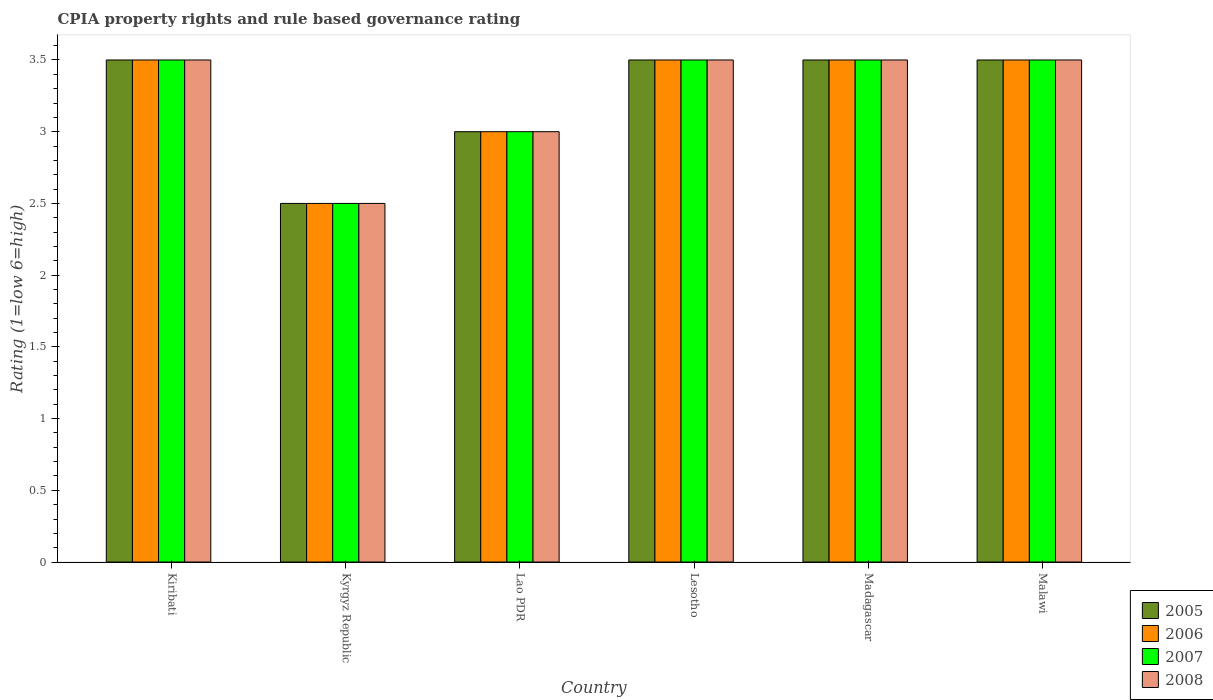How many groups of bars are there?
Your response must be concise. 6. How many bars are there on the 5th tick from the right?
Offer a terse response. 4. What is the label of the 4th group of bars from the left?
Your response must be concise. Lesotho. Across all countries, what is the maximum CPIA rating in 2005?
Your answer should be compact. 3.5. In which country was the CPIA rating in 2006 maximum?
Your answer should be compact. Kiribati. In which country was the CPIA rating in 2006 minimum?
Provide a succinct answer. Kyrgyz Republic. What is the difference between the CPIA rating in 2005 in Kiribati and that in Lao PDR?
Ensure brevity in your answer.  0.5. What is the difference between the CPIA rating in 2008 in Kyrgyz Republic and the CPIA rating in 2005 in Lesotho?
Provide a succinct answer. -1. What is the average CPIA rating in 2005 per country?
Offer a terse response. 3.25. What is the difference between the CPIA rating of/in 2007 and CPIA rating of/in 2006 in Lao PDR?
Your answer should be compact. 0. In how many countries, is the CPIA rating in 2006 greater than 3.4?
Provide a succinct answer. 4. What is the ratio of the CPIA rating in 2006 in Lesotho to that in Malawi?
Keep it short and to the point. 1. Is the sum of the CPIA rating in 2005 in Lesotho and Madagascar greater than the maximum CPIA rating in 2006 across all countries?
Provide a short and direct response. Yes. Is it the case that in every country, the sum of the CPIA rating in 2005 and CPIA rating in 2008 is greater than the sum of CPIA rating in 2006 and CPIA rating in 2007?
Your answer should be compact. No. What does the 4th bar from the left in Lao PDR represents?
Ensure brevity in your answer.  2008. What does the 1st bar from the right in Lao PDR represents?
Offer a very short reply. 2008. Are the values on the major ticks of Y-axis written in scientific E-notation?
Provide a succinct answer. No. Does the graph contain any zero values?
Keep it short and to the point. No. Where does the legend appear in the graph?
Offer a very short reply. Bottom right. How many legend labels are there?
Ensure brevity in your answer.  4. What is the title of the graph?
Your response must be concise. CPIA property rights and rule based governance rating. What is the label or title of the X-axis?
Make the answer very short. Country. What is the label or title of the Y-axis?
Keep it short and to the point. Rating (1=low 6=high). What is the Rating (1=low 6=high) of 2007 in Kiribati?
Offer a very short reply. 3.5. What is the Rating (1=low 6=high) of 2008 in Kiribati?
Give a very brief answer. 3.5. What is the Rating (1=low 6=high) in 2005 in Lao PDR?
Provide a short and direct response. 3. What is the Rating (1=low 6=high) in 2007 in Lao PDR?
Your answer should be compact. 3. What is the Rating (1=low 6=high) in 2006 in Lesotho?
Your answer should be very brief. 3.5. What is the Rating (1=low 6=high) in 2007 in Lesotho?
Your answer should be very brief. 3.5. What is the Rating (1=low 6=high) in 2008 in Lesotho?
Give a very brief answer. 3.5. What is the Rating (1=low 6=high) of 2005 in Madagascar?
Your answer should be very brief. 3.5. What is the Rating (1=low 6=high) in 2007 in Madagascar?
Your answer should be very brief. 3.5. What is the Rating (1=low 6=high) in 2008 in Malawi?
Offer a very short reply. 3.5. Across all countries, what is the maximum Rating (1=low 6=high) in 2007?
Your answer should be compact. 3.5. Across all countries, what is the minimum Rating (1=low 6=high) in 2006?
Offer a very short reply. 2.5. Across all countries, what is the minimum Rating (1=low 6=high) in 2007?
Make the answer very short. 2.5. Across all countries, what is the minimum Rating (1=low 6=high) in 2008?
Your answer should be very brief. 2.5. What is the total Rating (1=low 6=high) of 2006 in the graph?
Your response must be concise. 19.5. What is the total Rating (1=low 6=high) in 2007 in the graph?
Your answer should be very brief. 19.5. What is the total Rating (1=low 6=high) in 2008 in the graph?
Offer a terse response. 19.5. What is the difference between the Rating (1=low 6=high) of 2005 in Kiribati and that in Kyrgyz Republic?
Your response must be concise. 1. What is the difference between the Rating (1=low 6=high) in 2006 in Kiribati and that in Kyrgyz Republic?
Offer a very short reply. 1. What is the difference between the Rating (1=low 6=high) of 2007 in Kiribati and that in Kyrgyz Republic?
Keep it short and to the point. 1. What is the difference between the Rating (1=low 6=high) in 2008 in Kiribati and that in Kyrgyz Republic?
Keep it short and to the point. 1. What is the difference between the Rating (1=low 6=high) in 2006 in Kiribati and that in Lao PDR?
Give a very brief answer. 0.5. What is the difference between the Rating (1=low 6=high) in 2007 in Kiribati and that in Lao PDR?
Offer a very short reply. 0.5. What is the difference between the Rating (1=low 6=high) in 2008 in Kiribati and that in Lao PDR?
Give a very brief answer. 0.5. What is the difference between the Rating (1=low 6=high) in 2005 in Kiribati and that in Lesotho?
Your answer should be very brief. 0. What is the difference between the Rating (1=low 6=high) of 2008 in Kiribati and that in Lesotho?
Offer a very short reply. 0. What is the difference between the Rating (1=low 6=high) of 2005 in Kiribati and that in Malawi?
Offer a terse response. 0. What is the difference between the Rating (1=low 6=high) of 2008 in Kiribati and that in Malawi?
Ensure brevity in your answer.  0. What is the difference between the Rating (1=low 6=high) in 2006 in Kyrgyz Republic and that in Lao PDR?
Ensure brevity in your answer.  -0.5. What is the difference between the Rating (1=low 6=high) of 2007 in Kyrgyz Republic and that in Lao PDR?
Your answer should be compact. -0.5. What is the difference between the Rating (1=low 6=high) in 2008 in Kyrgyz Republic and that in Lao PDR?
Make the answer very short. -0.5. What is the difference between the Rating (1=low 6=high) of 2005 in Kyrgyz Republic and that in Lesotho?
Your answer should be compact. -1. What is the difference between the Rating (1=low 6=high) of 2006 in Kyrgyz Republic and that in Lesotho?
Give a very brief answer. -1. What is the difference between the Rating (1=low 6=high) in 2007 in Kyrgyz Republic and that in Lesotho?
Offer a terse response. -1. What is the difference between the Rating (1=low 6=high) of 2008 in Kyrgyz Republic and that in Lesotho?
Provide a succinct answer. -1. What is the difference between the Rating (1=low 6=high) in 2007 in Kyrgyz Republic and that in Madagascar?
Your answer should be very brief. -1. What is the difference between the Rating (1=low 6=high) in 2008 in Kyrgyz Republic and that in Madagascar?
Your response must be concise. -1. What is the difference between the Rating (1=low 6=high) in 2005 in Kyrgyz Republic and that in Malawi?
Offer a very short reply. -1. What is the difference between the Rating (1=low 6=high) of 2006 in Kyrgyz Republic and that in Malawi?
Offer a very short reply. -1. What is the difference between the Rating (1=low 6=high) in 2007 in Kyrgyz Republic and that in Malawi?
Make the answer very short. -1. What is the difference between the Rating (1=low 6=high) of 2008 in Kyrgyz Republic and that in Malawi?
Make the answer very short. -1. What is the difference between the Rating (1=low 6=high) in 2005 in Lao PDR and that in Lesotho?
Ensure brevity in your answer.  -0.5. What is the difference between the Rating (1=low 6=high) of 2007 in Lao PDR and that in Lesotho?
Offer a very short reply. -0.5. What is the difference between the Rating (1=low 6=high) of 2008 in Lao PDR and that in Lesotho?
Give a very brief answer. -0.5. What is the difference between the Rating (1=low 6=high) in 2005 in Lao PDR and that in Madagascar?
Offer a terse response. -0.5. What is the difference between the Rating (1=low 6=high) in 2005 in Lao PDR and that in Malawi?
Give a very brief answer. -0.5. What is the difference between the Rating (1=low 6=high) of 2006 in Lao PDR and that in Malawi?
Your answer should be very brief. -0.5. What is the difference between the Rating (1=low 6=high) of 2008 in Lao PDR and that in Malawi?
Provide a short and direct response. -0.5. What is the difference between the Rating (1=low 6=high) in 2005 in Lesotho and that in Madagascar?
Ensure brevity in your answer.  0. What is the difference between the Rating (1=low 6=high) in 2007 in Lesotho and that in Madagascar?
Offer a terse response. 0. What is the difference between the Rating (1=low 6=high) of 2008 in Lesotho and that in Madagascar?
Give a very brief answer. 0. What is the difference between the Rating (1=low 6=high) in 2005 in Lesotho and that in Malawi?
Keep it short and to the point. 0. What is the difference between the Rating (1=low 6=high) in 2006 in Lesotho and that in Malawi?
Ensure brevity in your answer.  0. What is the difference between the Rating (1=low 6=high) of 2007 in Lesotho and that in Malawi?
Your response must be concise. 0. What is the difference between the Rating (1=low 6=high) in 2008 in Lesotho and that in Malawi?
Give a very brief answer. 0. What is the difference between the Rating (1=low 6=high) in 2005 in Madagascar and that in Malawi?
Ensure brevity in your answer.  0. What is the difference between the Rating (1=low 6=high) of 2007 in Madagascar and that in Malawi?
Make the answer very short. 0. What is the difference between the Rating (1=low 6=high) in 2008 in Madagascar and that in Malawi?
Make the answer very short. 0. What is the difference between the Rating (1=low 6=high) of 2005 in Kiribati and the Rating (1=low 6=high) of 2007 in Kyrgyz Republic?
Offer a very short reply. 1. What is the difference between the Rating (1=low 6=high) in 2005 in Kiribati and the Rating (1=low 6=high) in 2008 in Kyrgyz Republic?
Your answer should be very brief. 1. What is the difference between the Rating (1=low 6=high) in 2006 in Kiribati and the Rating (1=low 6=high) in 2007 in Kyrgyz Republic?
Your answer should be compact. 1. What is the difference between the Rating (1=low 6=high) in 2006 in Kiribati and the Rating (1=low 6=high) in 2008 in Kyrgyz Republic?
Provide a succinct answer. 1. What is the difference between the Rating (1=low 6=high) of 2007 in Kiribati and the Rating (1=low 6=high) of 2008 in Kyrgyz Republic?
Provide a short and direct response. 1. What is the difference between the Rating (1=low 6=high) of 2005 in Kiribati and the Rating (1=low 6=high) of 2008 in Lao PDR?
Keep it short and to the point. 0.5. What is the difference between the Rating (1=low 6=high) in 2006 in Kiribati and the Rating (1=low 6=high) in 2007 in Lao PDR?
Your response must be concise. 0.5. What is the difference between the Rating (1=low 6=high) of 2007 in Kiribati and the Rating (1=low 6=high) of 2008 in Lao PDR?
Offer a terse response. 0.5. What is the difference between the Rating (1=low 6=high) in 2005 in Kiribati and the Rating (1=low 6=high) in 2007 in Lesotho?
Keep it short and to the point. 0. What is the difference between the Rating (1=low 6=high) in 2006 in Kiribati and the Rating (1=low 6=high) in 2007 in Lesotho?
Provide a succinct answer. 0. What is the difference between the Rating (1=low 6=high) of 2005 in Kiribati and the Rating (1=low 6=high) of 2006 in Madagascar?
Keep it short and to the point. 0. What is the difference between the Rating (1=low 6=high) in 2006 in Kiribati and the Rating (1=low 6=high) in 2007 in Madagascar?
Provide a succinct answer. 0. What is the difference between the Rating (1=low 6=high) in 2006 in Kiribati and the Rating (1=low 6=high) in 2008 in Madagascar?
Ensure brevity in your answer.  0. What is the difference between the Rating (1=low 6=high) of 2007 in Kiribati and the Rating (1=low 6=high) of 2008 in Madagascar?
Keep it short and to the point. 0. What is the difference between the Rating (1=low 6=high) of 2005 in Kiribati and the Rating (1=low 6=high) of 2008 in Malawi?
Provide a short and direct response. 0. What is the difference between the Rating (1=low 6=high) in 2005 in Kyrgyz Republic and the Rating (1=low 6=high) in 2006 in Lao PDR?
Your response must be concise. -0.5. What is the difference between the Rating (1=low 6=high) of 2005 in Kyrgyz Republic and the Rating (1=low 6=high) of 2008 in Lao PDR?
Provide a succinct answer. -0.5. What is the difference between the Rating (1=low 6=high) of 2006 in Kyrgyz Republic and the Rating (1=low 6=high) of 2008 in Lao PDR?
Offer a very short reply. -0.5. What is the difference between the Rating (1=low 6=high) in 2005 in Kyrgyz Republic and the Rating (1=low 6=high) in 2006 in Lesotho?
Offer a terse response. -1. What is the difference between the Rating (1=low 6=high) of 2005 in Kyrgyz Republic and the Rating (1=low 6=high) of 2007 in Lesotho?
Your answer should be compact. -1. What is the difference between the Rating (1=low 6=high) in 2006 in Kyrgyz Republic and the Rating (1=low 6=high) in 2007 in Lesotho?
Offer a terse response. -1. What is the difference between the Rating (1=low 6=high) in 2006 in Kyrgyz Republic and the Rating (1=low 6=high) in 2008 in Lesotho?
Provide a succinct answer. -1. What is the difference between the Rating (1=low 6=high) in 2007 in Kyrgyz Republic and the Rating (1=low 6=high) in 2008 in Lesotho?
Keep it short and to the point. -1. What is the difference between the Rating (1=low 6=high) of 2005 in Kyrgyz Republic and the Rating (1=low 6=high) of 2007 in Madagascar?
Your answer should be compact. -1. What is the difference between the Rating (1=low 6=high) of 2005 in Kyrgyz Republic and the Rating (1=low 6=high) of 2008 in Madagascar?
Offer a very short reply. -1. What is the difference between the Rating (1=low 6=high) of 2006 in Kyrgyz Republic and the Rating (1=low 6=high) of 2007 in Madagascar?
Ensure brevity in your answer.  -1. What is the difference between the Rating (1=low 6=high) of 2006 in Kyrgyz Republic and the Rating (1=low 6=high) of 2008 in Madagascar?
Ensure brevity in your answer.  -1. What is the difference between the Rating (1=low 6=high) in 2007 in Kyrgyz Republic and the Rating (1=low 6=high) in 2008 in Madagascar?
Offer a terse response. -1. What is the difference between the Rating (1=low 6=high) of 2005 in Kyrgyz Republic and the Rating (1=low 6=high) of 2006 in Malawi?
Provide a short and direct response. -1. What is the difference between the Rating (1=low 6=high) in 2005 in Kyrgyz Republic and the Rating (1=low 6=high) in 2007 in Malawi?
Offer a very short reply. -1. What is the difference between the Rating (1=low 6=high) in 2006 in Kyrgyz Republic and the Rating (1=low 6=high) in 2007 in Malawi?
Your response must be concise. -1. What is the difference between the Rating (1=low 6=high) in 2006 in Kyrgyz Republic and the Rating (1=low 6=high) in 2008 in Malawi?
Make the answer very short. -1. What is the difference between the Rating (1=low 6=high) of 2005 in Lao PDR and the Rating (1=low 6=high) of 2006 in Lesotho?
Provide a short and direct response. -0.5. What is the difference between the Rating (1=low 6=high) in 2006 in Lao PDR and the Rating (1=low 6=high) in 2007 in Lesotho?
Offer a terse response. -0.5. What is the difference between the Rating (1=low 6=high) in 2006 in Lao PDR and the Rating (1=low 6=high) in 2008 in Lesotho?
Give a very brief answer. -0.5. What is the difference between the Rating (1=low 6=high) of 2006 in Lao PDR and the Rating (1=low 6=high) of 2007 in Madagascar?
Your response must be concise. -0.5. What is the difference between the Rating (1=low 6=high) in 2007 in Lao PDR and the Rating (1=low 6=high) in 2008 in Madagascar?
Provide a succinct answer. -0.5. What is the difference between the Rating (1=low 6=high) in 2005 in Lao PDR and the Rating (1=low 6=high) in 2006 in Malawi?
Your answer should be compact. -0.5. What is the difference between the Rating (1=low 6=high) in 2005 in Lao PDR and the Rating (1=low 6=high) in 2007 in Malawi?
Your response must be concise. -0.5. What is the difference between the Rating (1=low 6=high) in 2005 in Lesotho and the Rating (1=low 6=high) in 2006 in Madagascar?
Your response must be concise. 0. What is the difference between the Rating (1=low 6=high) in 2005 in Lesotho and the Rating (1=low 6=high) in 2007 in Madagascar?
Offer a very short reply. 0. What is the difference between the Rating (1=low 6=high) of 2006 in Lesotho and the Rating (1=low 6=high) of 2007 in Madagascar?
Your answer should be compact. 0. What is the difference between the Rating (1=low 6=high) in 2005 in Lesotho and the Rating (1=low 6=high) in 2006 in Malawi?
Offer a terse response. 0. What is the difference between the Rating (1=low 6=high) in 2005 in Lesotho and the Rating (1=low 6=high) in 2008 in Malawi?
Provide a succinct answer. 0. What is the difference between the Rating (1=low 6=high) in 2006 in Lesotho and the Rating (1=low 6=high) in 2008 in Malawi?
Offer a terse response. 0. What is the difference between the Rating (1=low 6=high) in 2007 in Lesotho and the Rating (1=low 6=high) in 2008 in Malawi?
Offer a terse response. 0. What is the difference between the Rating (1=low 6=high) in 2006 in Madagascar and the Rating (1=low 6=high) in 2007 in Malawi?
Your answer should be very brief. 0. What is the difference between the Rating (1=low 6=high) of 2007 in Madagascar and the Rating (1=low 6=high) of 2008 in Malawi?
Give a very brief answer. 0. What is the average Rating (1=low 6=high) in 2007 per country?
Provide a short and direct response. 3.25. What is the average Rating (1=low 6=high) in 2008 per country?
Your answer should be very brief. 3.25. What is the difference between the Rating (1=low 6=high) of 2005 and Rating (1=low 6=high) of 2006 in Kiribati?
Make the answer very short. 0. What is the difference between the Rating (1=low 6=high) of 2006 and Rating (1=low 6=high) of 2007 in Kiribati?
Keep it short and to the point. 0. What is the difference between the Rating (1=low 6=high) of 2007 and Rating (1=low 6=high) of 2008 in Kiribati?
Provide a succinct answer. 0. What is the difference between the Rating (1=low 6=high) of 2005 and Rating (1=low 6=high) of 2006 in Kyrgyz Republic?
Offer a very short reply. 0. What is the difference between the Rating (1=low 6=high) in 2005 and Rating (1=low 6=high) in 2007 in Kyrgyz Republic?
Give a very brief answer. 0. What is the difference between the Rating (1=low 6=high) in 2005 and Rating (1=low 6=high) in 2008 in Kyrgyz Republic?
Ensure brevity in your answer.  0. What is the difference between the Rating (1=low 6=high) in 2006 and Rating (1=low 6=high) in 2007 in Kyrgyz Republic?
Your response must be concise. 0. What is the difference between the Rating (1=low 6=high) in 2007 and Rating (1=low 6=high) in 2008 in Kyrgyz Republic?
Give a very brief answer. 0. What is the difference between the Rating (1=low 6=high) in 2005 and Rating (1=low 6=high) in 2008 in Lao PDR?
Make the answer very short. 0. What is the difference between the Rating (1=low 6=high) of 2007 and Rating (1=low 6=high) of 2008 in Lao PDR?
Your response must be concise. 0. What is the difference between the Rating (1=low 6=high) in 2005 and Rating (1=low 6=high) in 2006 in Lesotho?
Keep it short and to the point. 0. What is the difference between the Rating (1=low 6=high) of 2005 and Rating (1=low 6=high) of 2007 in Lesotho?
Ensure brevity in your answer.  0. What is the difference between the Rating (1=low 6=high) in 2006 and Rating (1=low 6=high) in 2007 in Lesotho?
Give a very brief answer. 0. What is the difference between the Rating (1=low 6=high) of 2006 and Rating (1=low 6=high) of 2007 in Madagascar?
Offer a terse response. 0. What is the difference between the Rating (1=low 6=high) of 2006 and Rating (1=low 6=high) of 2008 in Madagascar?
Ensure brevity in your answer.  0. What is the difference between the Rating (1=low 6=high) of 2006 and Rating (1=low 6=high) of 2007 in Malawi?
Your response must be concise. 0. What is the difference between the Rating (1=low 6=high) in 2006 and Rating (1=low 6=high) in 2008 in Malawi?
Your answer should be very brief. 0. What is the difference between the Rating (1=low 6=high) of 2007 and Rating (1=low 6=high) of 2008 in Malawi?
Ensure brevity in your answer.  0. What is the ratio of the Rating (1=low 6=high) in 2005 in Kiribati to that in Kyrgyz Republic?
Your response must be concise. 1.4. What is the ratio of the Rating (1=low 6=high) in 2007 in Kiribati to that in Kyrgyz Republic?
Keep it short and to the point. 1.4. What is the ratio of the Rating (1=low 6=high) of 2005 in Kiribati to that in Lao PDR?
Offer a terse response. 1.17. What is the ratio of the Rating (1=low 6=high) of 2007 in Kiribati to that in Lao PDR?
Give a very brief answer. 1.17. What is the ratio of the Rating (1=low 6=high) in 2005 in Kiribati to that in Lesotho?
Ensure brevity in your answer.  1. What is the ratio of the Rating (1=low 6=high) in 2008 in Kiribati to that in Lesotho?
Offer a very short reply. 1. What is the ratio of the Rating (1=low 6=high) of 2007 in Kiribati to that in Madagascar?
Keep it short and to the point. 1. What is the ratio of the Rating (1=low 6=high) of 2005 in Kiribati to that in Malawi?
Offer a terse response. 1. What is the ratio of the Rating (1=low 6=high) of 2005 in Kyrgyz Republic to that in Lao PDR?
Provide a short and direct response. 0.83. What is the ratio of the Rating (1=low 6=high) in 2008 in Kyrgyz Republic to that in Lao PDR?
Offer a very short reply. 0.83. What is the ratio of the Rating (1=low 6=high) of 2006 in Kyrgyz Republic to that in Lesotho?
Provide a short and direct response. 0.71. What is the ratio of the Rating (1=low 6=high) in 2007 in Kyrgyz Republic to that in Lesotho?
Make the answer very short. 0.71. What is the ratio of the Rating (1=low 6=high) in 2006 in Kyrgyz Republic to that in Madagascar?
Ensure brevity in your answer.  0.71. What is the ratio of the Rating (1=low 6=high) of 2007 in Kyrgyz Republic to that in Madagascar?
Your response must be concise. 0.71. What is the ratio of the Rating (1=low 6=high) in 2008 in Kyrgyz Republic to that in Malawi?
Offer a terse response. 0.71. What is the ratio of the Rating (1=low 6=high) of 2005 in Lao PDR to that in Lesotho?
Your answer should be very brief. 0.86. What is the ratio of the Rating (1=low 6=high) of 2007 in Lao PDR to that in Lesotho?
Keep it short and to the point. 0.86. What is the ratio of the Rating (1=low 6=high) in 2007 in Lao PDR to that in Madagascar?
Give a very brief answer. 0.86. What is the ratio of the Rating (1=low 6=high) of 2005 in Lao PDR to that in Malawi?
Give a very brief answer. 0.86. What is the ratio of the Rating (1=low 6=high) in 2006 in Lao PDR to that in Malawi?
Offer a terse response. 0.86. What is the ratio of the Rating (1=low 6=high) of 2005 in Lesotho to that in Madagascar?
Provide a succinct answer. 1. What is the ratio of the Rating (1=low 6=high) of 2006 in Lesotho to that in Madagascar?
Make the answer very short. 1. What is the ratio of the Rating (1=low 6=high) in 2007 in Lesotho to that in Madagascar?
Ensure brevity in your answer.  1. What is the ratio of the Rating (1=low 6=high) in 2008 in Lesotho to that in Madagascar?
Make the answer very short. 1. What is the ratio of the Rating (1=low 6=high) of 2005 in Lesotho to that in Malawi?
Offer a very short reply. 1. What is the ratio of the Rating (1=low 6=high) of 2007 in Lesotho to that in Malawi?
Give a very brief answer. 1. What is the ratio of the Rating (1=low 6=high) in 2008 in Lesotho to that in Malawi?
Provide a short and direct response. 1. What is the ratio of the Rating (1=low 6=high) of 2005 in Madagascar to that in Malawi?
Your answer should be very brief. 1. What is the ratio of the Rating (1=low 6=high) of 2006 in Madagascar to that in Malawi?
Keep it short and to the point. 1. What is the ratio of the Rating (1=low 6=high) in 2007 in Madagascar to that in Malawi?
Ensure brevity in your answer.  1. What is the ratio of the Rating (1=low 6=high) in 2008 in Madagascar to that in Malawi?
Offer a very short reply. 1. What is the difference between the highest and the second highest Rating (1=low 6=high) of 2006?
Your answer should be very brief. 0. What is the difference between the highest and the second highest Rating (1=low 6=high) of 2007?
Ensure brevity in your answer.  0. What is the difference between the highest and the lowest Rating (1=low 6=high) in 2005?
Offer a very short reply. 1. What is the difference between the highest and the lowest Rating (1=low 6=high) in 2006?
Make the answer very short. 1. What is the difference between the highest and the lowest Rating (1=low 6=high) in 2007?
Give a very brief answer. 1. 